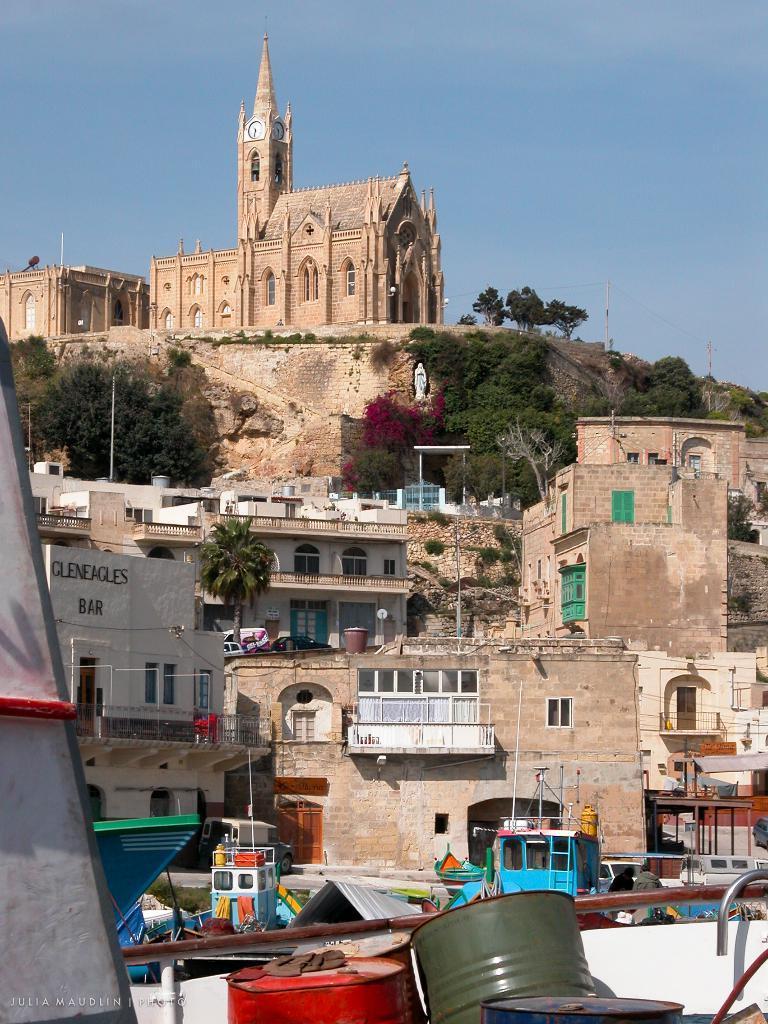How would you summarize this image in a sentence or two? In this image I can see few metal barrels which are orange and green in color. I can see few boats, few buildings which are brown and white in color and in the background I can see a mountains, few trees on the mountain, a building which is brown in color on the mountain and to the building I can see a clock and the sky in the background. 